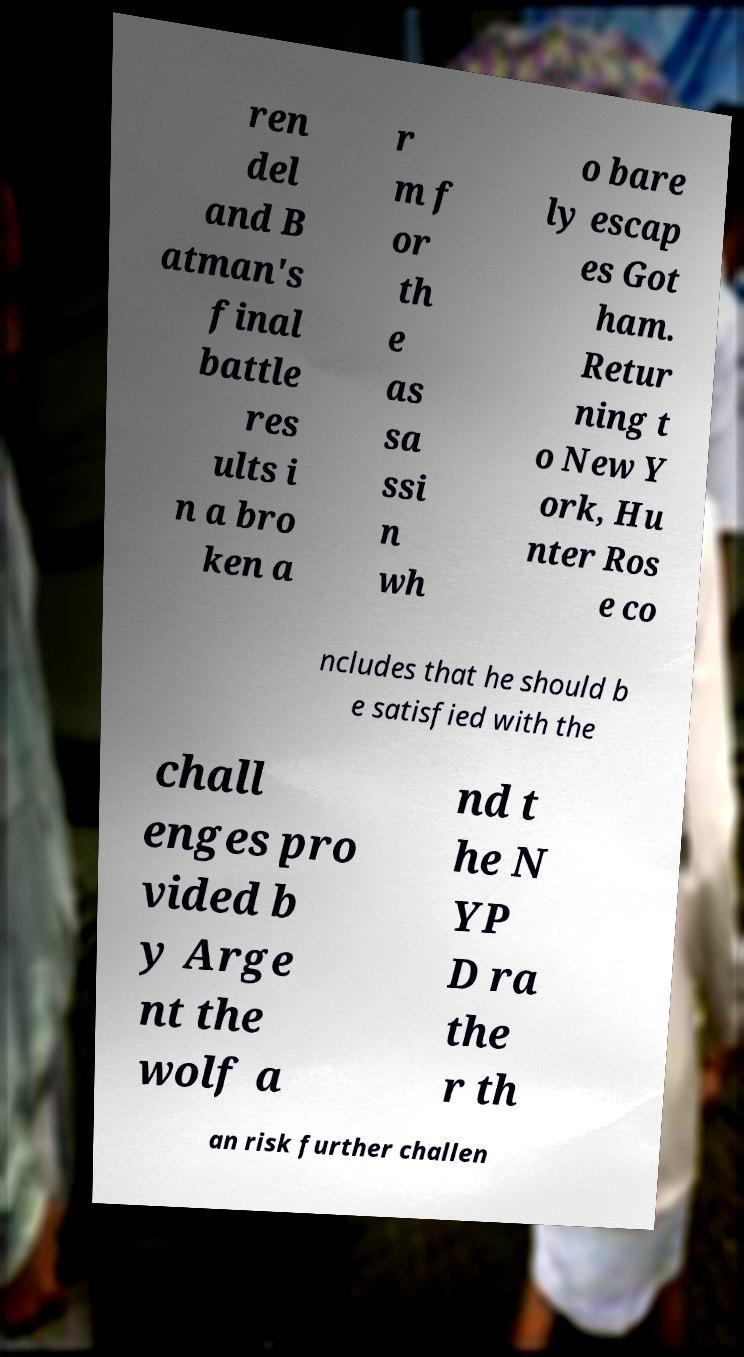What messages or text are displayed in this image? I need them in a readable, typed format. ren del and B atman's final battle res ults i n a bro ken a r m f or th e as sa ssi n wh o bare ly escap es Got ham. Retur ning t o New Y ork, Hu nter Ros e co ncludes that he should b e satisfied with the chall enges pro vided b y Arge nt the wolf a nd t he N YP D ra the r th an risk further challen 